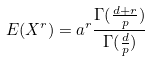Convert formula to latex. <formula><loc_0><loc_0><loc_500><loc_500>E ( X ^ { r } ) = a ^ { r } \frac { \Gamma ( \frac { d + r } { p } ) } { \Gamma ( \frac { d } { p } ) }</formula> 